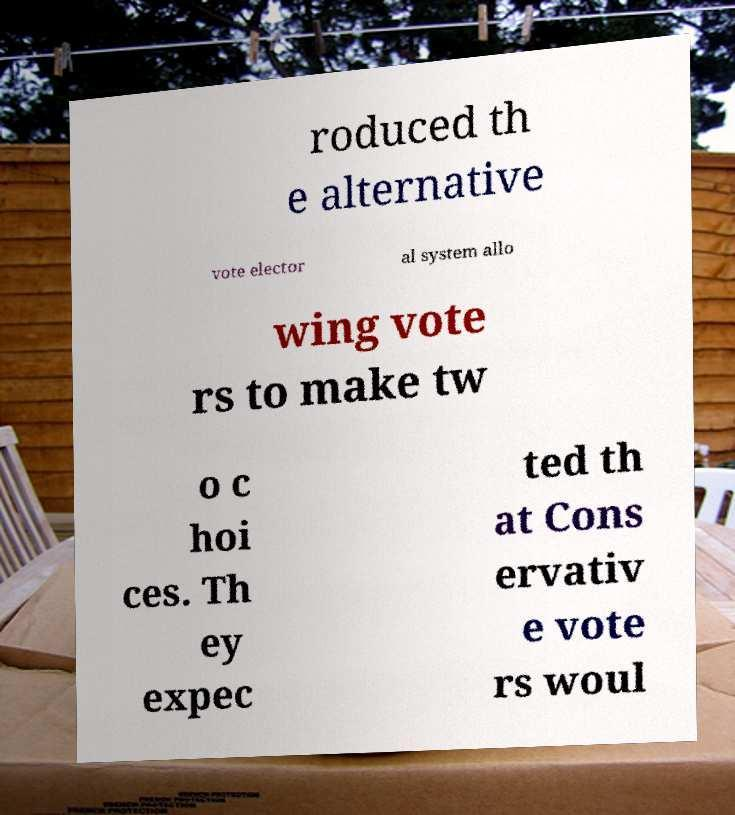Could you assist in decoding the text presented in this image and type it out clearly? roduced th e alternative vote elector al system allo wing vote rs to make tw o c hoi ces. Th ey expec ted th at Cons ervativ e vote rs woul 